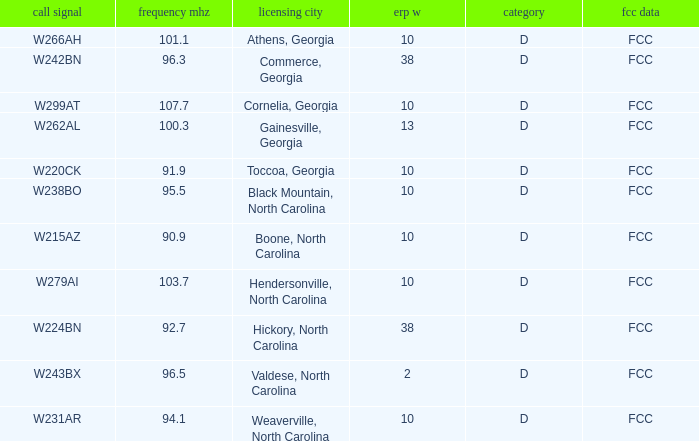What is the FCC frequency for the station w262al which has a Frequency MHz larger than 92.7? FCC. 